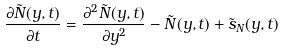Convert formula to latex. <formula><loc_0><loc_0><loc_500><loc_500>\frac { \partial \tilde { N } ( y , t ) } { \partial t } = \frac { \partial ^ { 2 } \tilde { N } ( y , t ) } { \partial y ^ { 2 } } - \tilde { N } ( y , t ) + \tilde { s } _ { N } ( y , t )</formula> 